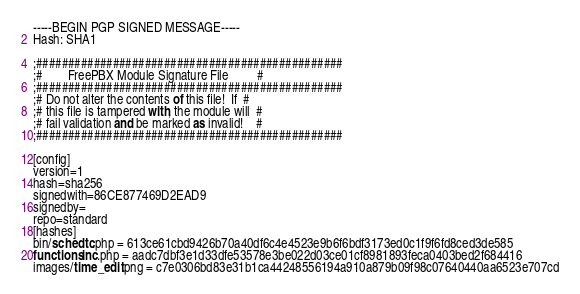<code> <loc_0><loc_0><loc_500><loc_500><_SML_>-----BEGIN PGP SIGNED MESSAGE-----
Hash: SHA1

;################################################
;#        FreePBX Module Signature File         #
;################################################
;# Do not alter the contents of this file!  If  #
;# this file is tampered with, the module will  #
;# fail validation and be marked as invalid!    #
;################################################

[config]
version=1
hash=sha256
signedwith=86CE877469D2EAD9
signedby=
repo=standard
[hashes]
bin/schedtc.php = 613ce61cbd9426b70a40df6c4e4523e9b6f6bdf3173ed0c1f9f6fd8ced3de585
functions.inc.php = aadc7dbf3e1d33dfe53578e3be022d03ce01cf8981893feca0403bed2f684416
images/time_edit.png = c7e0306bd83e31b1ca44248556194a910a879b09f98c07640440aa6523e707cd</code> 